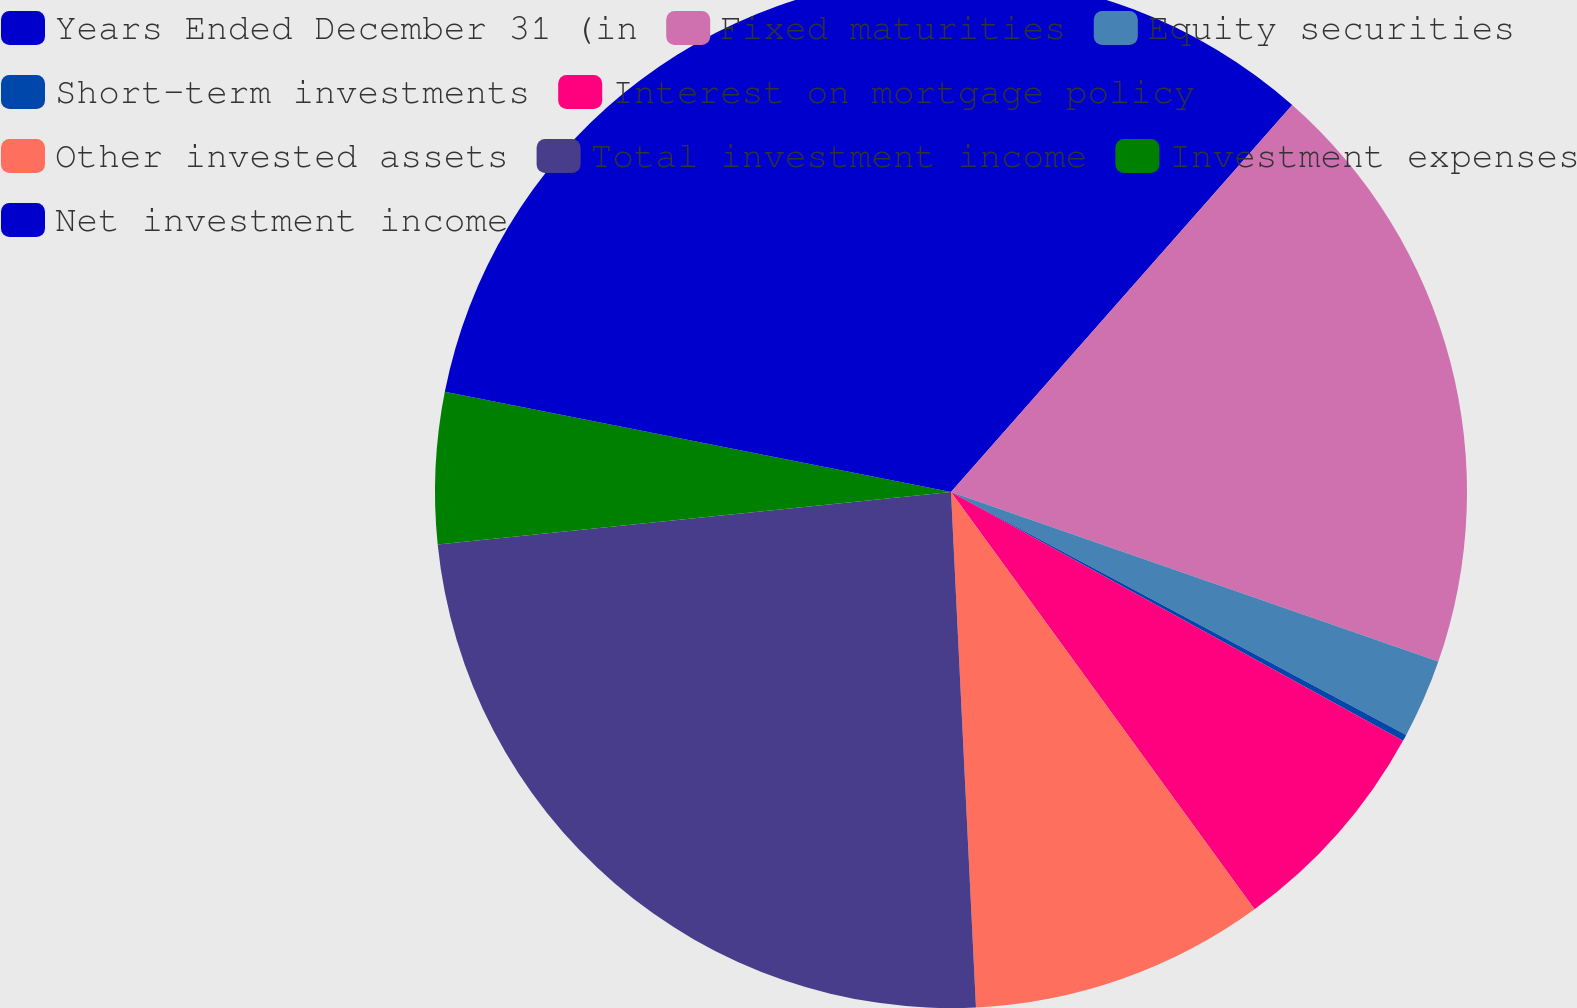<chart> <loc_0><loc_0><loc_500><loc_500><pie_chart><fcel>Years Ended December 31 (in<fcel>Fixed maturities<fcel>Equity securities<fcel>Short-term investments<fcel>Interest on mortgage policy<fcel>Other invested assets<fcel>Total investment income<fcel>Investment expenses<fcel>Net investment income<nl><fcel>11.5%<fcel>18.83%<fcel>2.47%<fcel>0.21%<fcel>6.98%<fcel>9.24%<fcel>24.15%<fcel>4.73%<fcel>21.89%<nl></chart> 